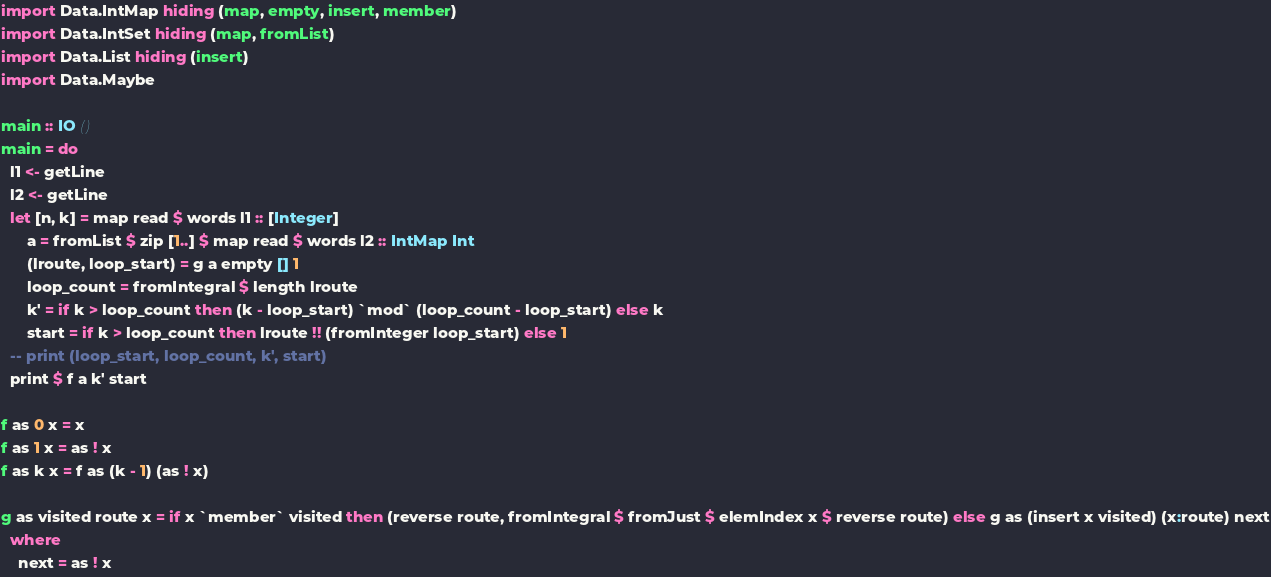<code> <loc_0><loc_0><loc_500><loc_500><_Haskell_>import Data.IntMap hiding (map, empty, insert, member)
import Data.IntSet hiding (map, fromList)
import Data.List hiding (insert)
import Data.Maybe

main :: IO ()
main = do
  l1 <- getLine
  l2 <- getLine
  let [n, k] = map read $ words l1 :: [Integer]
      a = fromList $ zip [1..] $ map read $ words l2 :: IntMap Int
      (lroute, loop_start) = g a empty [] 1
      loop_count = fromIntegral $ length lroute
      k' = if k > loop_count then (k - loop_start) `mod` (loop_count - loop_start) else k
      start = if k > loop_count then lroute !! (fromInteger loop_start) else 1
  -- print (loop_start, loop_count, k', start)
  print $ f a k' start

f as 0 x = x
f as 1 x = as ! x
f as k x = f as (k - 1) (as ! x)

g as visited route x = if x `member` visited then (reverse route, fromIntegral $ fromJust $ elemIndex x $ reverse route) else g as (insert x visited) (x:route) next
  where
    next = as ! x</code> 